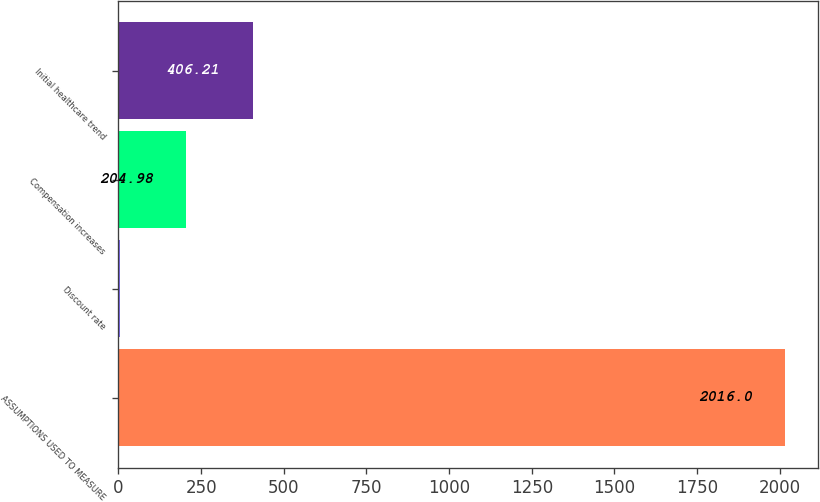Convert chart to OTSL. <chart><loc_0><loc_0><loc_500><loc_500><bar_chart><fcel>ASSUMPTIONS USED TO MEASURE<fcel>Discount rate<fcel>Compensation increases<fcel>Initial healthcare trend<nl><fcel>2016<fcel>3.75<fcel>204.98<fcel>406.21<nl></chart> 